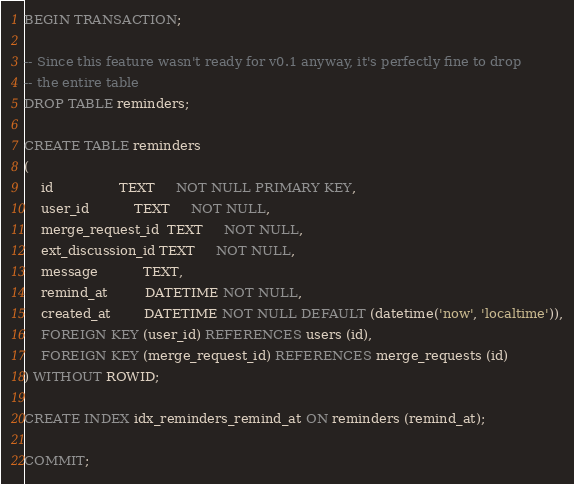Convert code to text. <code><loc_0><loc_0><loc_500><loc_500><_SQL_>BEGIN TRANSACTION;

-- Since this feature wasn't ready for v0.1 anyway, it's perfectly fine to drop
-- the entire table
DROP TABLE reminders;

CREATE TABLE reminders
(
    id                TEXT     NOT NULL PRIMARY KEY,
    user_id           TEXT     NOT NULL,
    merge_request_id  TEXT     NOT NULL,
    ext_discussion_id TEXT     NOT NULL,
    message           TEXT,
    remind_at         DATETIME NOT NULL,
    created_at        DATETIME NOT NULL DEFAULT (datetime('now', 'localtime')),
    FOREIGN KEY (user_id) REFERENCES users (id),
    FOREIGN KEY (merge_request_id) REFERENCES merge_requests (id)
) WITHOUT ROWID;

CREATE INDEX idx_reminders_remind_at ON reminders (remind_at);

COMMIT;
</code> 